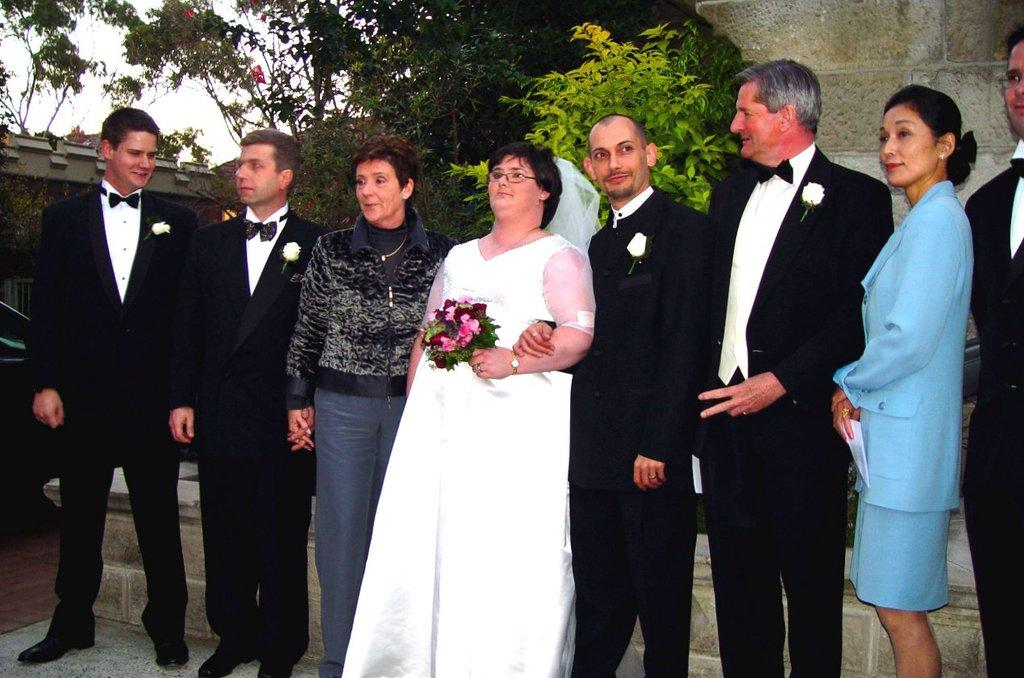What can be seen in the image? There are people standing in the image. Where are the people standing? The people are standing on the floor. What can be seen in the background of the image? There are buildings, trees, a vehicle, and the sky visible in the background of the image. What year is depicted in the image? The provided facts do not mention any specific year, so it cannot be determined from the image. 